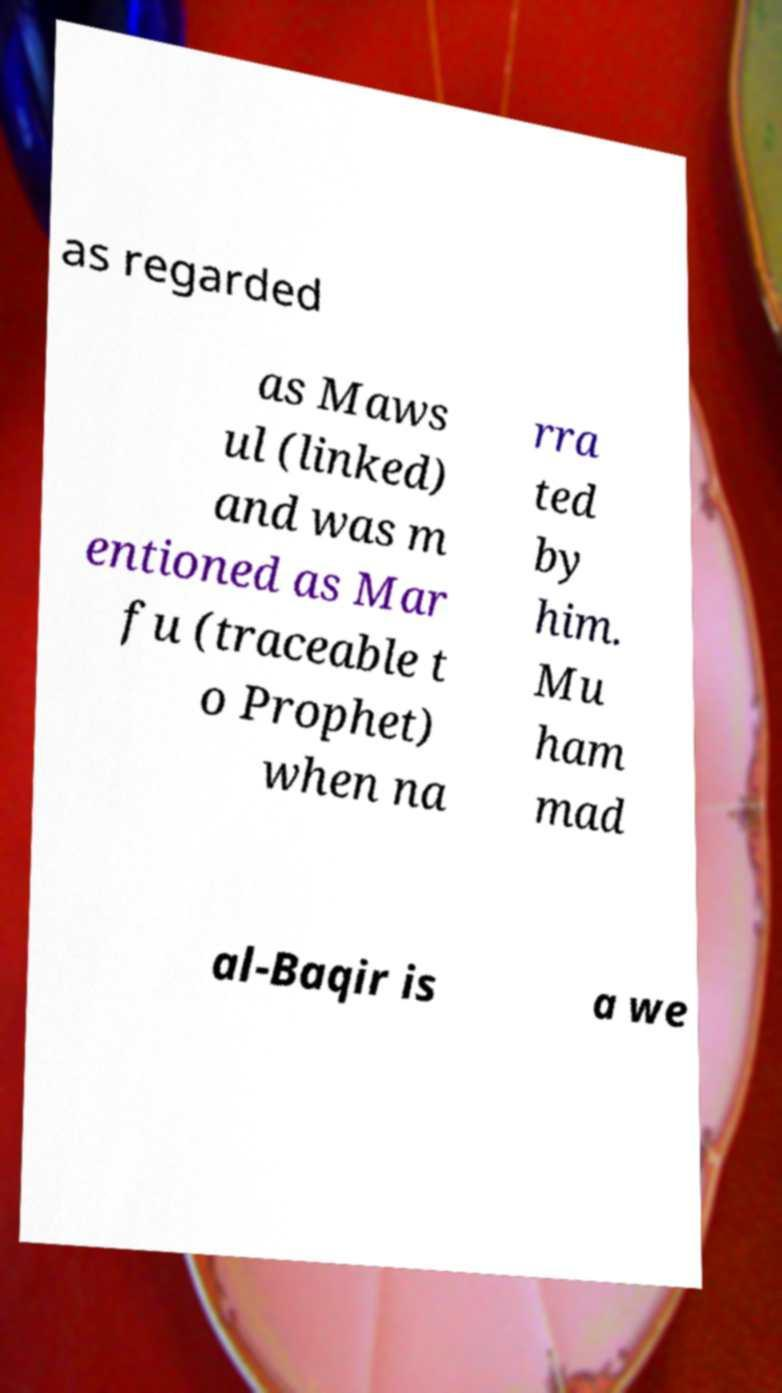What messages or text are displayed in this image? I need them in a readable, typed format. as regarded as Maws ul (linked) and was m entioned as Mar fu (traceable t o Prophet) when na rra ted by him. Mu ham mad al-Baqir is a we 